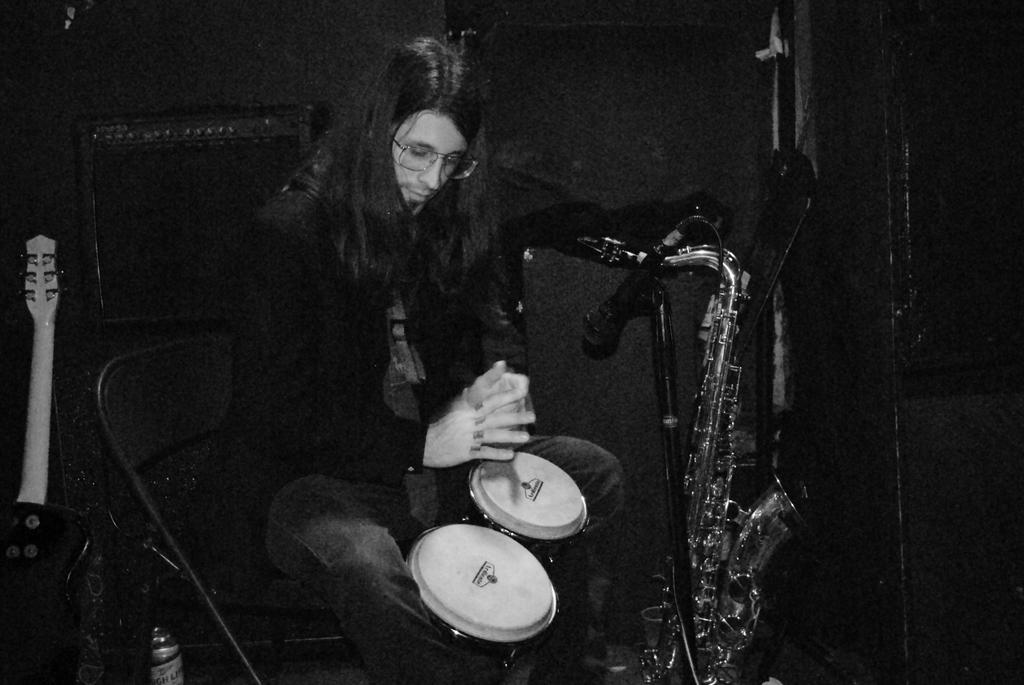What is the man in the image doing? The man is playing drums. What musical instrument is in front of the man? There is a saxophone in front of the man. How many sheep are visible in the image? There are no sheep present in the image. What type of hook is the man using to play the drums? The man is not using a hook to play the drums; he is using drumsticks. 